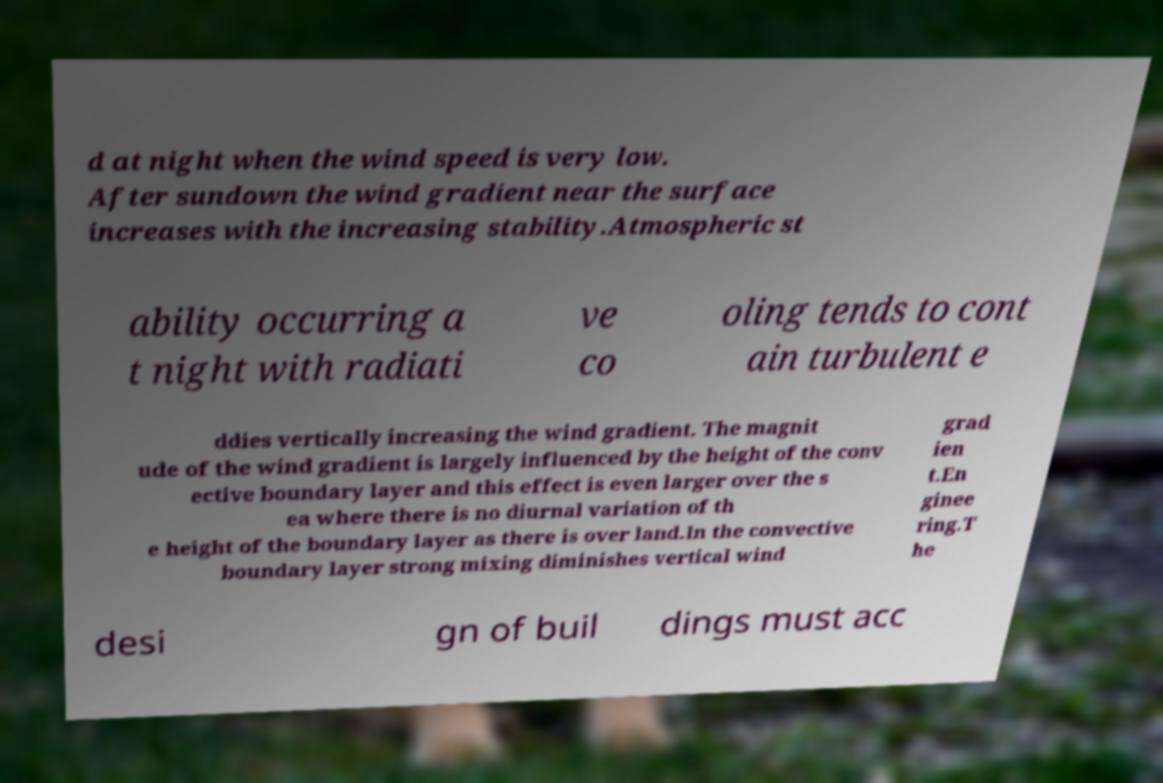There's text embedded in this image that I need extracted. Can you transcribe it verbatim? d at night when the wind speed is very low. After sundown the wind gradient near the surface increases with the increasing stability.Atmospheric st ability occurring a t night with radiati ve co oling tends to cont ain turbulent e ddies vertically increasing the wind gradient. The magnit ude of the wind gradient is largely influenced by the height of the conv ective boundary layer and this effect is even larger over the s ea where there is no diurnal variation of th e height of the boundary layer as there is over land.In the convective boundary layer strong mixing diminishes vertical wind grad ien t.En ginee ring.T he desi gn of buil dings must acc 